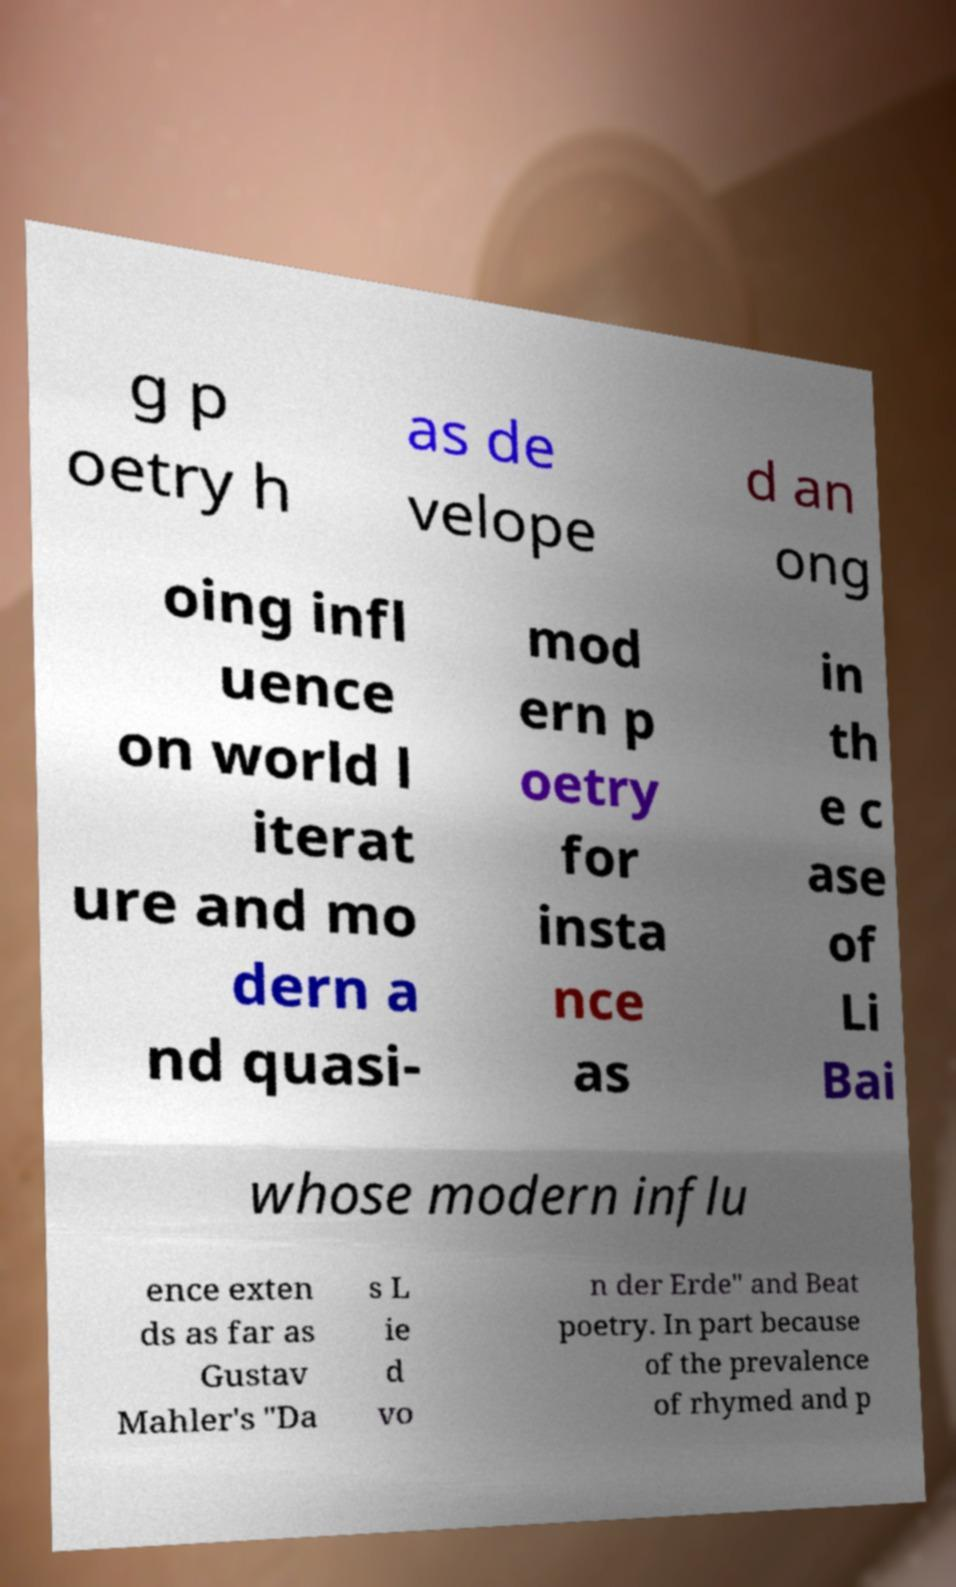I need the written content from this picture converted into text. Can you do that? g p oetry h as de velope d an ong oing infl uence on world l iterat ure and mo dern a nd quasi- mod ern p oetry for insta nce as in th e c ase of Li Bai whose modern influ ence exten ds as far as Gustav Mahler's "Da s L ie d vo n der Erde" and Beat poetry. In part because of the prevalence of rhymed and p 